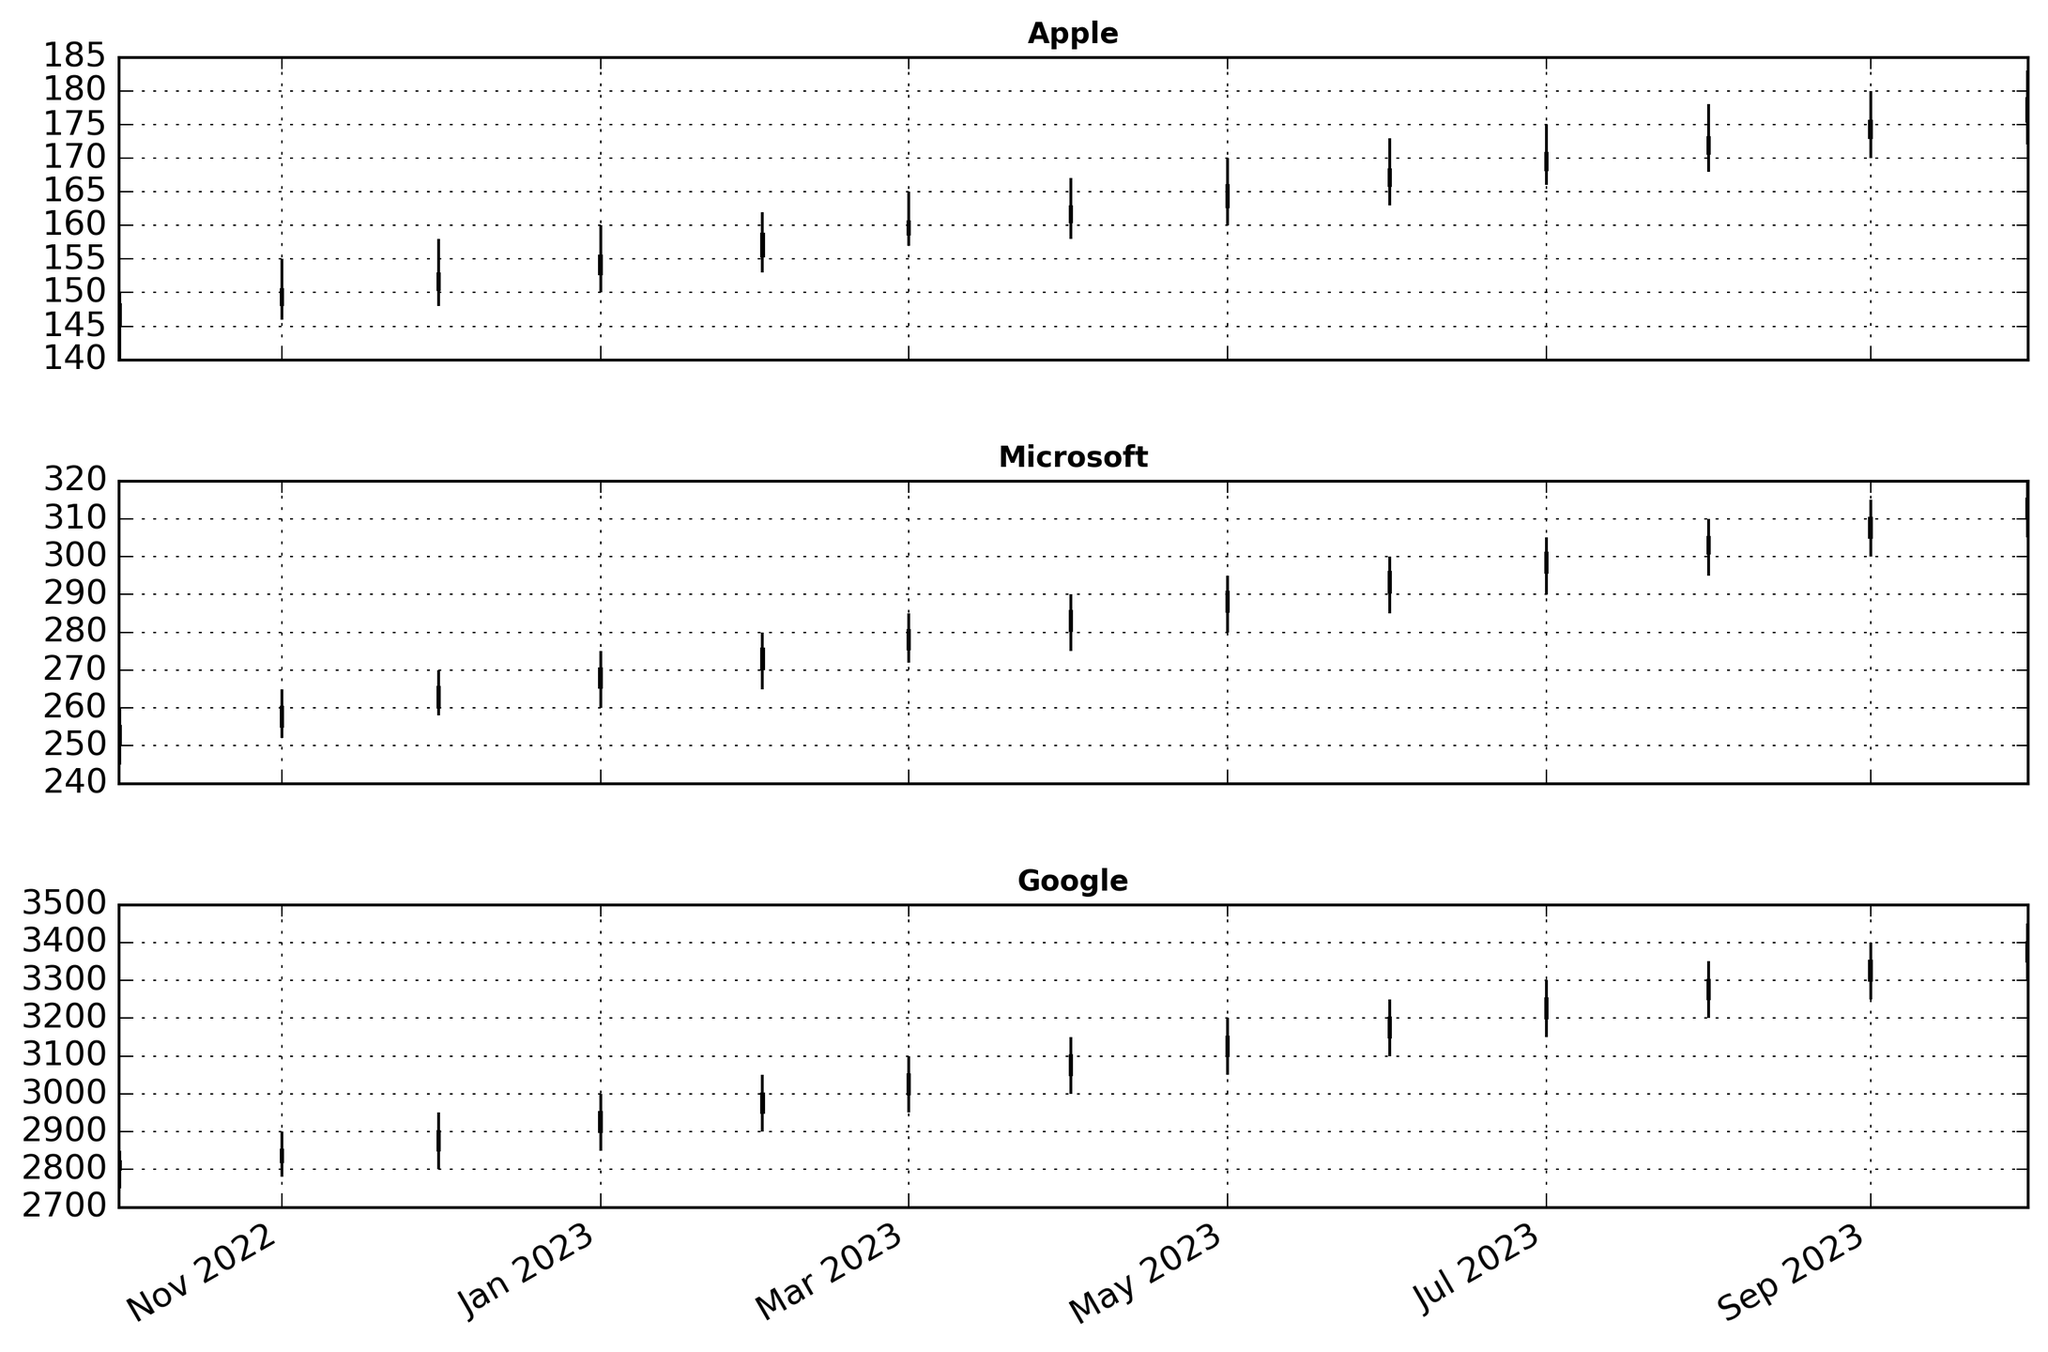What company showed the highest closing price in October 2023? Look at the highest point reached by the candlesticks in October 2023 for each company. Notice that Google's candlestick extends the furthest on the y-axis.
Answer: Google Comparing the price ranges in January 2023, which company had the largest difference between the high and low prices? Calculate the difference between the high and low prices for each company. For Apple: 160.00 - 150.00 = 10. Microsoft: 275.00 - 260.00 = 15. Google: 3000.00 - 2850.00 = 150. Google has the largest difference.
Answer: Google Was Apple's stock price overall increasing or decreasing from October 2022 to October 2023? Compare the opening price in October 2022 (145.30) with the closing price in October 2023 (178.90). Since 178.90 is greater than 145.30, Apple’s price is overall increasing.
Answer: Increasing Between Microsoft and Google, which company had a higher closing price more frequently over the year? Count the months in which Microsoft's closing price was higher than Google’s and vice versa. Microsoft: 0 months. Google: 12 months. Google had a higher closing price more frequently.
Answer: Google Which month did Apple see the highest closing price within the past year? Look at the highest points of the green candlesticks (indicating a net increase) for Apple. The highest point is in October 2023 with a closing price of 178.90.
Answer: October 2023 In which month did Microsoft have a significant drop in closing price compared to the previous month? Compare month-over-month changes in Microsoft's closing prices. Notice the drop from October 2022 (255.10) to November 2022 (260.20) is insignificant whereas other months are consistently increasing. There are no significant drops.
Answer: None What is the average closing price of Google in the first quarter of 2023? Sum the closing prices for January, February, and March: 2950.50, 3000.20, and 3050.30. The total is 2950.50 + 3000.20 + 3050.30 = 9001. Divide by 3 to get the average: 9001 / 3 ≈ 3000.33
Answer: 3000.33 Comparing the highest-high prices in June 2023, which company's stock peaked the highest? Compare the highest points of the candlesticks for each company in June 2023. Apple's highest high is 173.00. Microsoft's highest high is 300.00. Google's highest high is 3250.00. Google peaked the highest.
Answer: Google In which month did Apple’s closing price first exceed 160.00 within the past year? Look at the candlestick closing prices for Apple month by month until it exceeds 160.00. The first month is April 2023 with a closing price of 162.80.
Answer: April 2023 